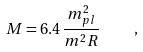<formula> <loc_0><loc_0><loc_500><loc_500>M = 6 . 4 \, \frac { m _ { p l } ^ { 2 } } { m ^ { 2 } R } \quad ,</formula> 